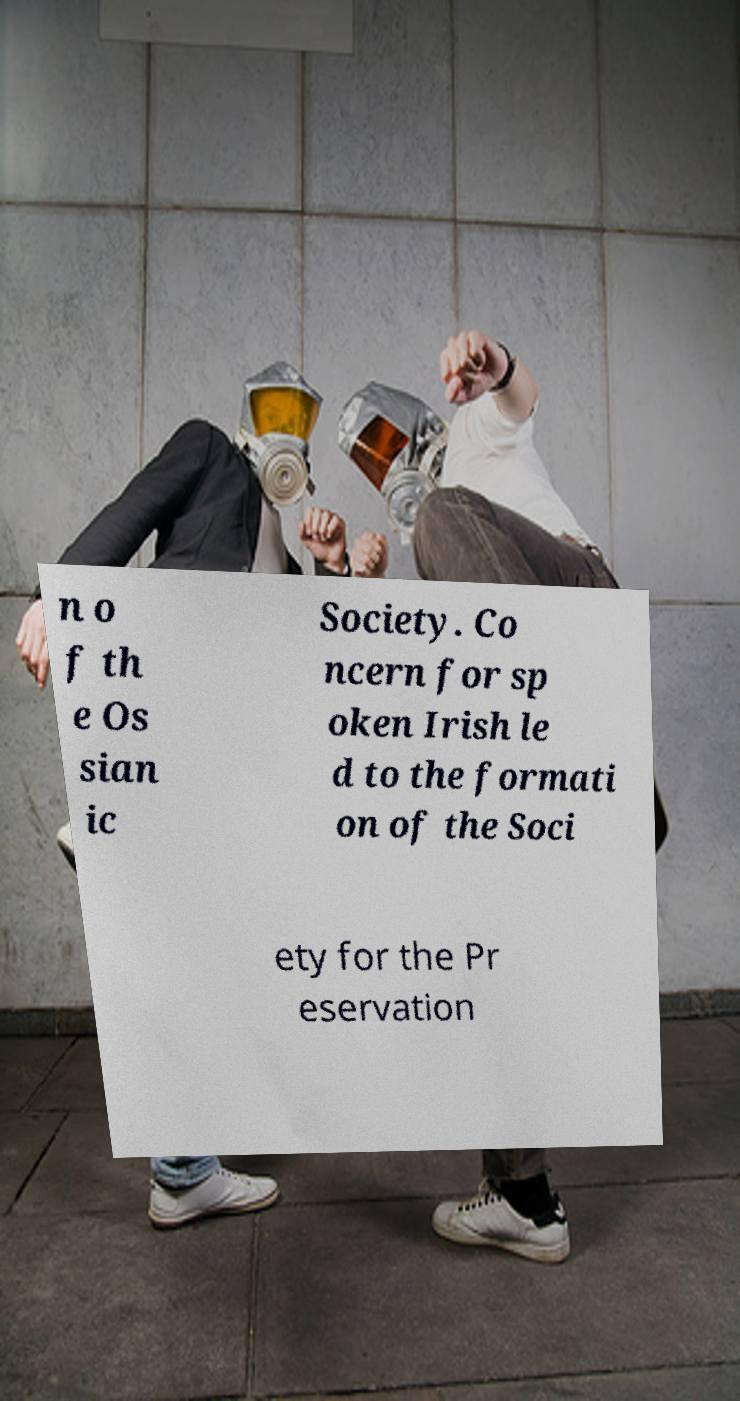There's text embedded in this image that I need extracted. Can you transcribe it verbatim? n o f th e Os sian ic Society. Co ncern for sp oken Irish le d to the formati on of the Soci ety for the Pr eservation 